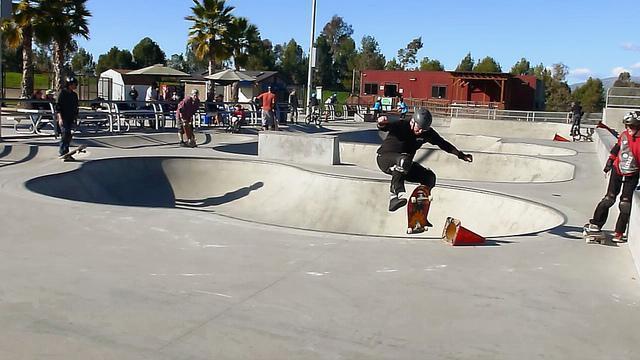Why have the skaters covered their heads?
Select the accurate answer and provide justification: `Answer: choice
Rationale: srationale.`
Options: Warmth, uniform, fashion, protection. Answer: protection.
Rationale: The skaters need safety. 